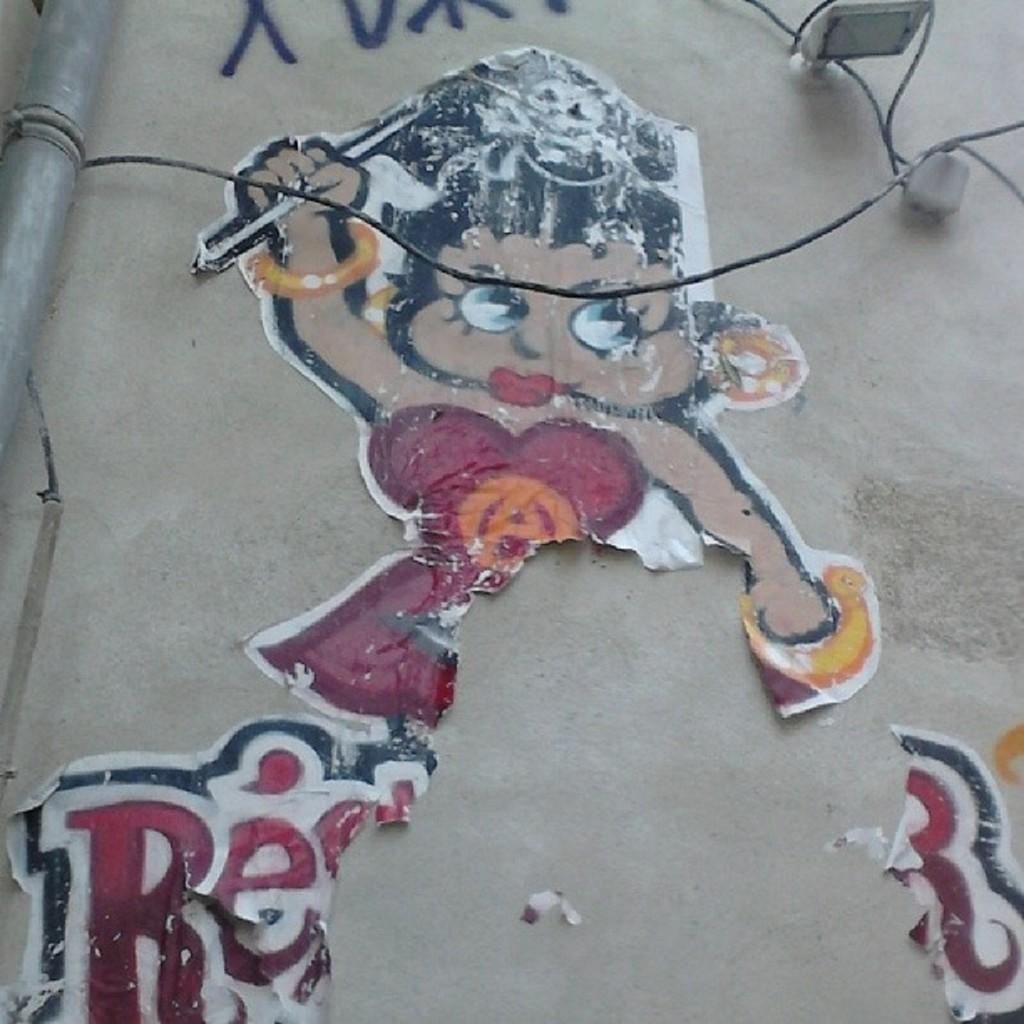Can you describe this image briefly? In this image, we can see the wall with some posters, text and some objects. We can also see the pole and some wires. 